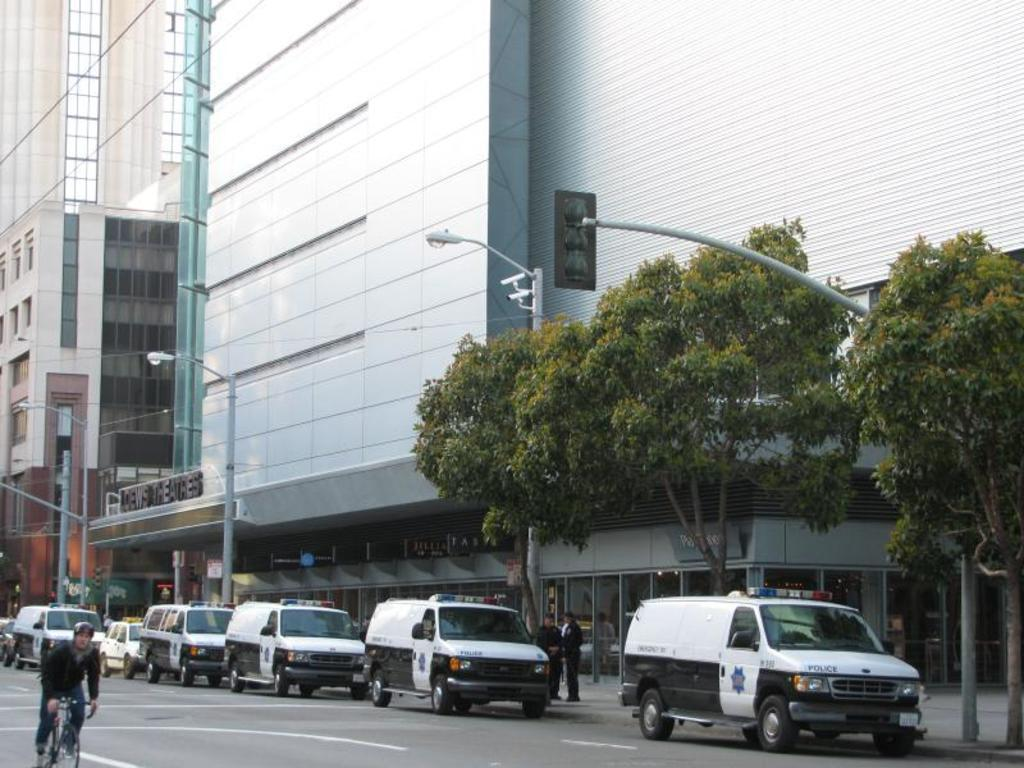What type of structures can be seen in the image? There are buildings in the image. What can be seen illuminating the scene in the image? There are lights in the image. What mode of transportation is present in the image? There are vehicles in the image. What activity is a person engaged in within the image? A person is riding a bicycle in the image. What are the people in the image doing? People are standing on the ground in the image. What type of vegetation is visible in the background of the image? Trees are present in the background of the image. What type of signal is used to regulate traffic in the image? Traffic lights are visible in the image. What type of fiction is the person reading while riding the bicycle in the image? There is no person reading fiction while riding a bicycle in the image. How does the person stretch their legs while riding the bicycle in the image? The person is not stretching their legs while riding the bicycle in the image. 